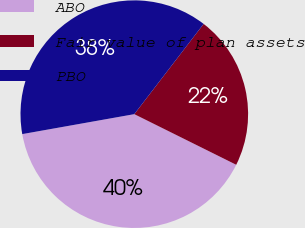Convert chart. <chart><loc_0><loc_0><loc_500><loc_500><pie_chart><fcel>ABO<fcel>Fair value of plan assets<fcel>PBO<nl><fcel>39.86%<fcel>21.91%<fcel>38.23%<nl></chart> 